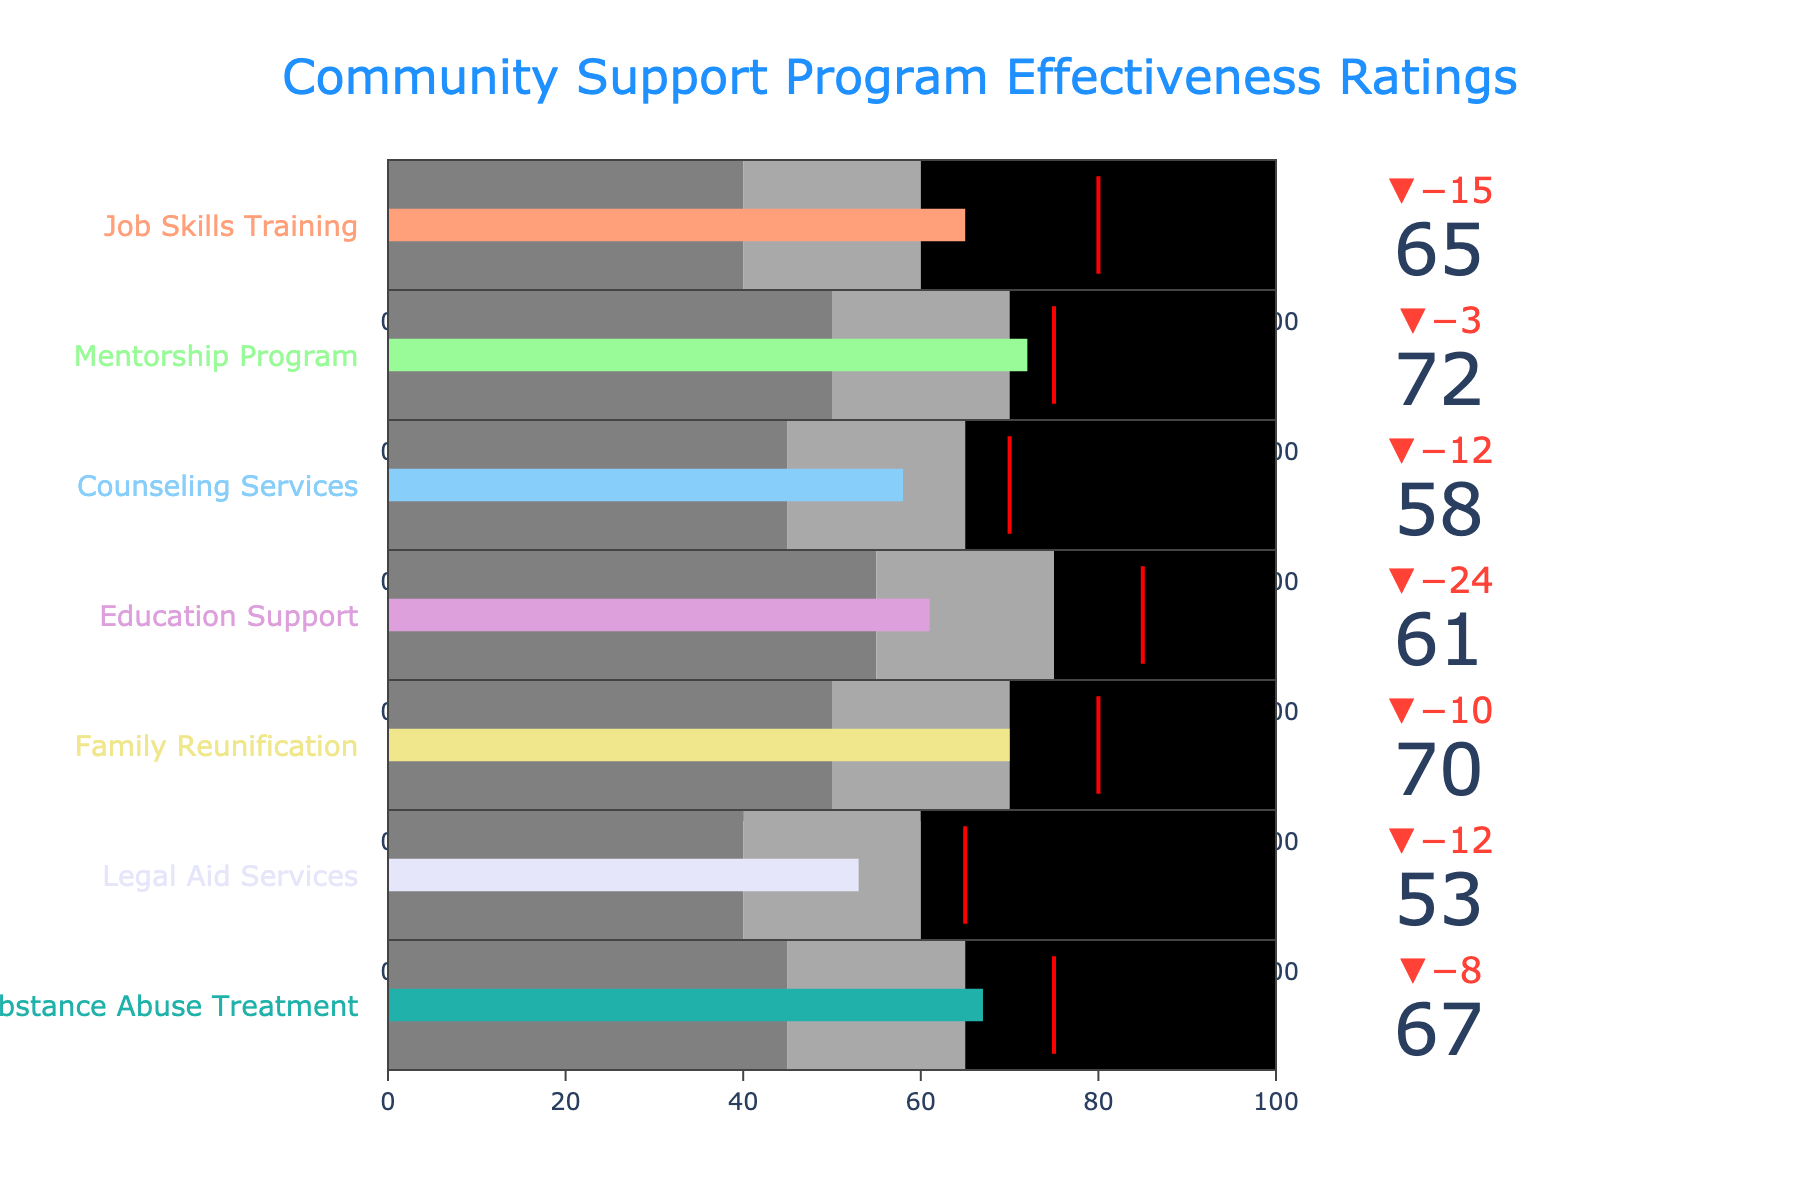What's the title of the chart? The title is usually shown at the top of the chart. Here, it reads "Community Support Program Effectiveness Ratings".
Answer: Community Support Program Effectiveness Ratings How many programs are evaluated in the chart? Count the number of distinct programs listed on the y-axis or in the titles of the bullet indicators.
Answer: 7 Which program has the highest actual effectiveness rating? Compare the actual effectiveness values for all programs. The Mentorship Program has the highest value at 72.
Answer: Mentorship Program What is the target effectiveness rating for Job Skills Training? Look at the target value line for the Job Skills Training bullet indicator.
Answer: 80 Which two programs have their actual effectiveness ratings closer to their target values? Calculate the absolute differences between the actual and target values for each program. The smaller the difference, the closer the actual value is to the target. Mentorship Program (3) and Family Reunification (10).
Answer: Mentorship Program and Family Reunification Which program has the poorest performance compared to its target effectiveness rating? Find the program with the largest negative difference between actual and target values. Legal Aid Services shows a difference of 12 from 65 to 53, the largest gap.
Answer: Legal Aid Services How does the Counseling Services program compare against its target? Observe the actual value of Counseling Services (58) and compare it to its target value (70). The actual value is below the target, underperforming by 12.
Answer: It is underperforming by 12 What is the poorest acceptable (satisfactory) rating for the Legal Aid Services program? Identify the lower bound of the satisfactory range for Legal Aid Services by looking at its color-coded satisfactory range.
Answer: 40 If we rank all programs by their actual effectiveness rating, which program is third best? List all actual effectiveness values and sort in descending order: Mentorship Program (72), Family Reunification (70), Substance Abuse Treatment (67).
Answer: Substance Abuse Treatment In how many programs did the actual effectiveness exceed the satisfactory threshold? For each program, see if the actual effectiveness rating is greater than or equal to the satisfactory value. The programs are Job Skills Training, Mentorship Program, Family Reunification, and Substance Abuse Treatment.
Answer: 4 